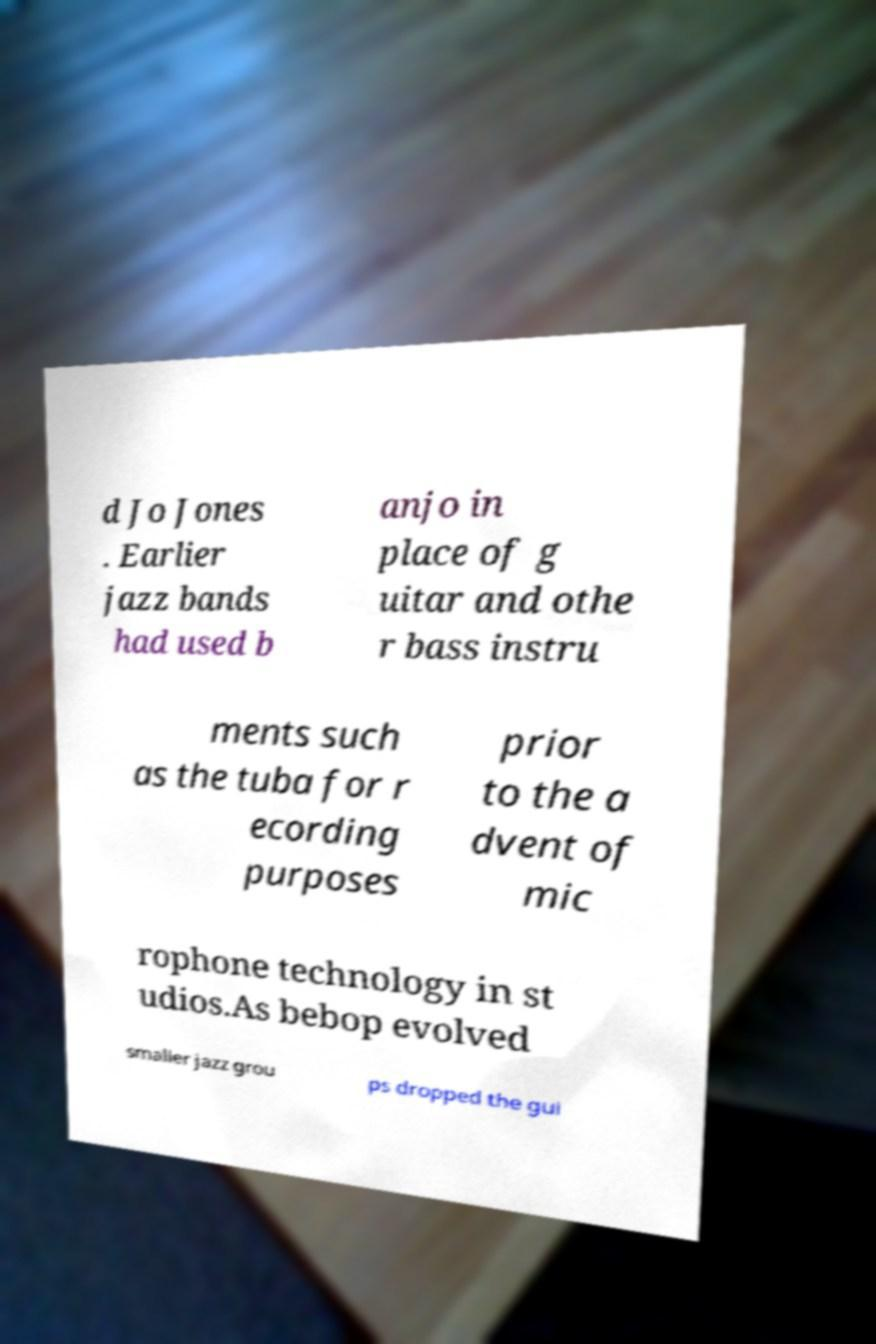Can you accurately transcribe the text from the provided image for me? d Jo Jones . Earlier jazz bands had used b anjo in place of g uitar and othe r bass instru ments such as the tuba for r ecording purposes prior to the a dvent of mic rophone technology in st udios.As bebop evolved smaller jazz grou ps dropped the gui 